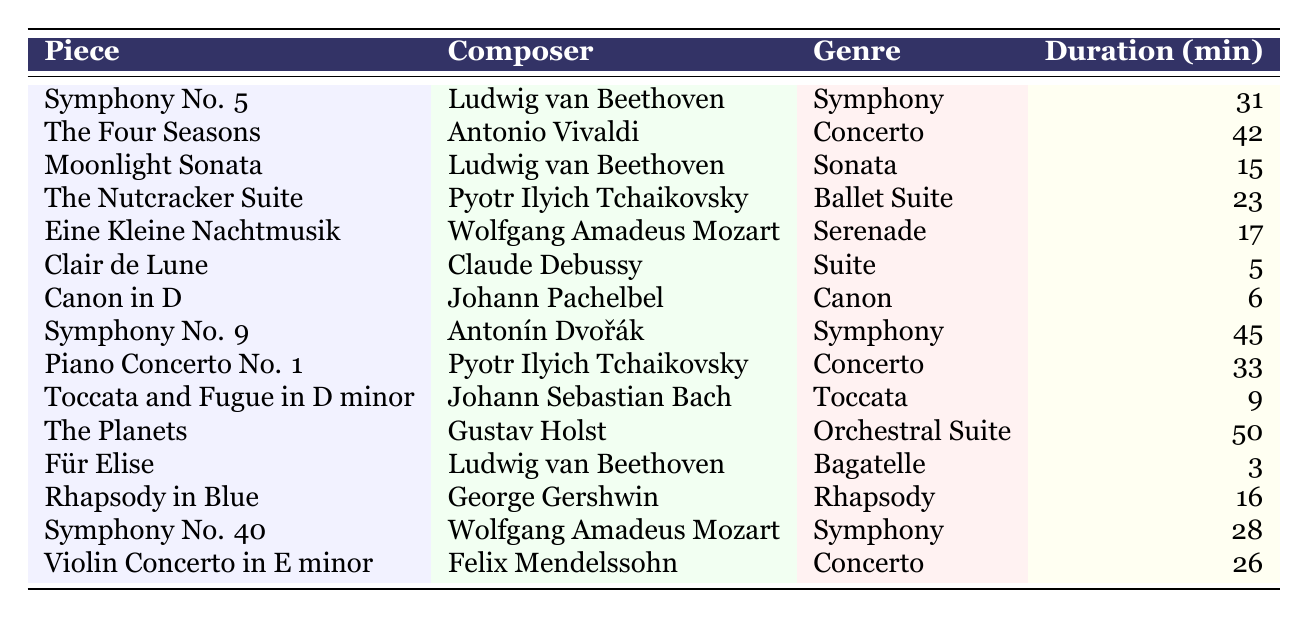What is the duration of "The Four Seasons"? The table lists "The Four Seasons" with a duration of 42 minutes.
Answer: 42 minutes Who composed "Clair de Lune"? The table states that "Clair de Lune" was composed by Claude Debussy.
Answer: Claude Debussy How many minutes does the "Piano Concerto No. 1" last? According to the table, "Piano Concerto No. 1" has a duration of 33 minutes.
Answer: 33 minutes Is "Moonlight Sonata" longer than "Für Elise"? "Moonlight Sonata" is 15 minutes long and "Für Elise" is 3 minutes long. Since 15 is greater than 3, the answer is yes.
Answer: Yes Which genre has the longest piece, and what is its duration? By reviewing the table, "The Planets" is the longest, with a duration of 50 minutes, and it falls under the Orchestral Suite genre.
Answer: Orchestral Suite, 50 minutes Calculate the average duration of all the symphonies listed. The durations for the symphonies are: 31, 45, and 28 minutes. Adding them gives 31 + 45 + 28 = 104 minutes. Dividing by 3 (the number of symphonies) gives an average of 104 / 3 = 34.67 minutes.
Answer: 34.67 minutes Which composer has the shortest piece in the table? Looking at the table, "Für Elise" by Ludwig van Beethoven is the shortest, lasting only 3 minutes.
Answer: Ludwig van Beethoven How many concerto pieces are listed, and what are their titles? The table contains three concertos: "The Four Seasons," "Piano Concerto No. 1," and "Violin Concerto in E minor."
Answer: 3 titles: "The Four Seasons," "Piano Concerto No. 1," "Violin Concerto in E minor" What is the total duration of all the concertos combined? The concertos listed are: 42, 33, and 26 minutes. Their total duration is calculated as 42 + 33 + 26 = 101 minutes.
Answer: 101 minutes Is there a piece shorter than 10 minutes, and if so, what is its name? Yes, according to the table, both "Clair de Lune" (5 minutes) and "Canon in D" (6 minutes) are shorter than 10 minutes.
Answer: Yes, "Clair de Lune" and "Canon in D" 